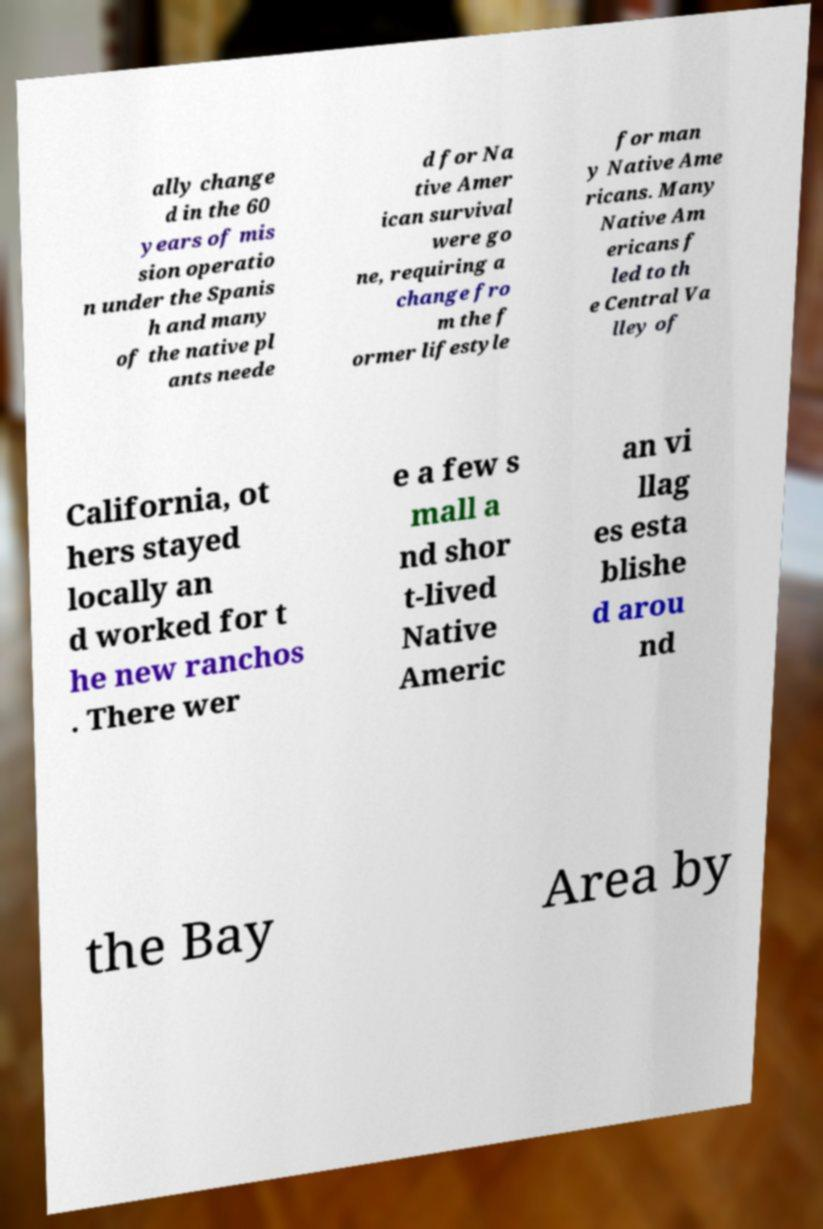Could you assist in decoding the text presented in this image and type it out clearly? ally change d in the 60 years of mis sion operatio n under the Spanis h and many of the native pl ants neede d for Na tive Amer ican survival were go ne, requiring a change fro m the f ormer lifestyle for man y Native Ame ricans. Many Native Am ericans f led to th e Central Va lley of California, ot hers stayed locally an d worked for t he new ranchos . There wer e a few s mall a nd shor t-lived Native Americ an vi llag es esta blishe d arou nd the Bay Area by 